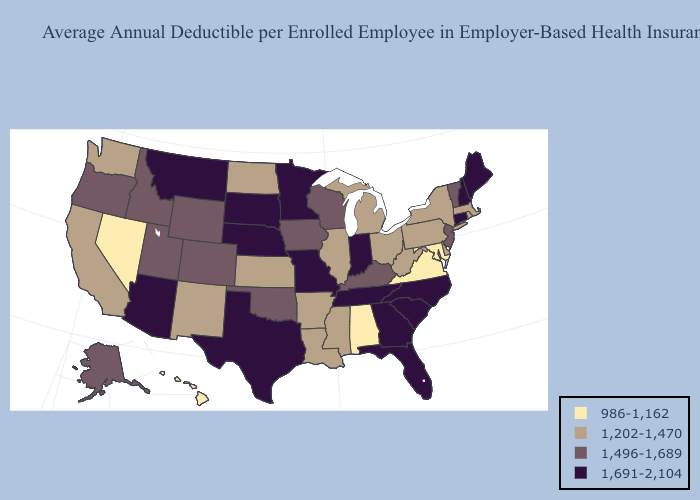Does South Dakota have the lowest value in the MidWest?
Short answer required. No. What is the highest value in the South ?
Answer briefly. 1,691-2,104. What is the highest value in states that border New Mexico?
Give a very brief answer. 1,691-2,104. What is the value of Maine?
Write a very short answer. 1,691-2,104. Name the states that have a value in the range 1,202-1,470?
Write a very short answer. Arkansas, California, Delaware, Illinois, Kansas, Louisiana, Massachusetts, Michigan, Mississippi, New Mexico, New York, North Dakota, Ohio, Pennsylvania, Rhode Island, Washington, West Virginia. Name the states that have a value in the range 1,202-1,470?
Short answer required. Arkansas, California, Delaware, Illinois, Kansas, Louisiana, Massachusetts, Michigan, Mississippi, New Mexico, New York, North Dakota, Ohio, Pennsylvania, Rhode Island, Washington, West Virginia. Name the states that have a value in the range 1,691-2,104?
Write a very short answer. Arizona, Connecticut, Florida, Georgia, Indiana, Maine, Minnesota, Missouri, Montana, Nebraska, New Hampshire, North Carolina, South Carolina, South Dakota, Tennessee, Texas. Does the first symbol in the legend represent the smallest category?
Write a very short answer. Yes. Name the states that have a value in the range 1,691-2,104?
Short answer required. Arizona, Connecticut, Florida, Georgia, Indiana, Maine, Minnesota, Missouri, Montana, Nebraska, New Hampshire, North Carolina, South Carolina, South Dakota, Tennessee, Texas. Among the states that border Kansas , which have the lowest value?
Be succinct. Colorado, Oklahoma. Name the states that have a value in the range 1,496-1,689?
Answer briefly. Alaska, Colorado, Idaho, Iowa, Kentucky, New Jersey, Oklahoma, Oregon, Utah, Vermont, Wisconsin, Wyoming. Which states have the highest value in the USA?
Keep it brief. Arizona, Connecticut, Florida, Georgia, Indiana, Maine, Minnesota, Missouri, Montana, Nebraska, New Hampshire, North Carolina, South Carolina, South Dakota, Tennessee, Texas. Name the states that have a value in the range 986-1,162?
Quick response, please. Alabama, Hawaii, Maryland, Nevada, Virginia. Name the states that have a value in the range 986-1,162?
Quick response, please. Alabama, Hawaii, Maryland, Nevada, Virginia. 